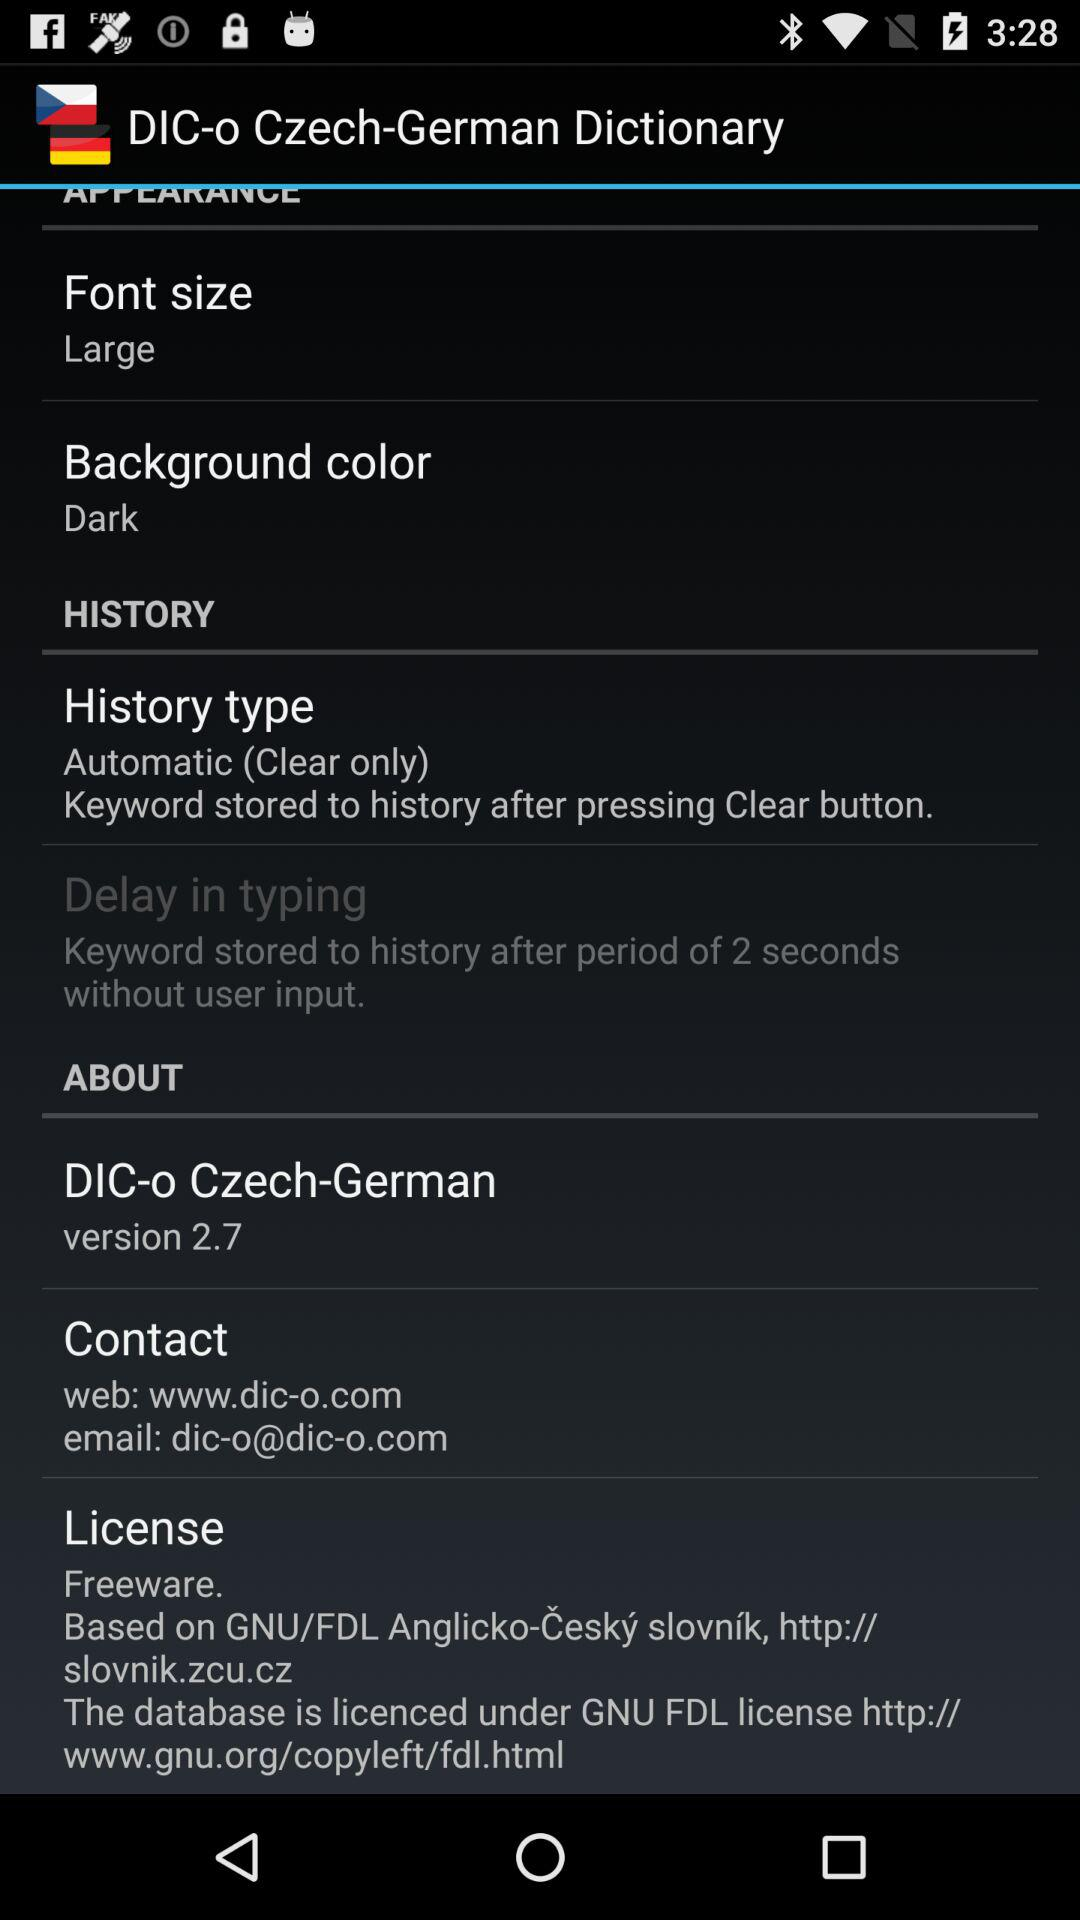What is the background color? The background color is dark. 